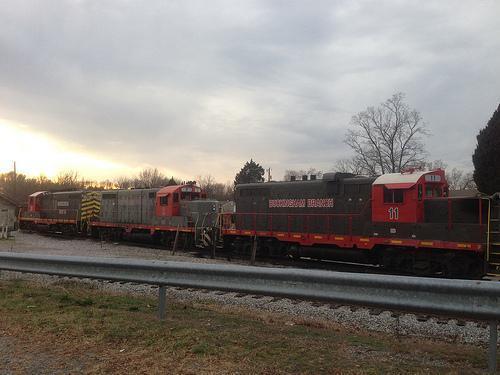How many engines are there?
Give a very brief answer. 3. 